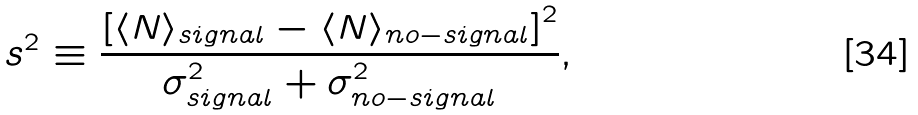<formula> <loc_0><loc_0><loc_500><loc_500>s ^ { 2 } \equiv \frac { { [ \langle N \rangle _ { s i g n a l } - \langle N \rangle _ { n o - s i g n a l } ] } ^ { 2 } } { \sigma ^ { 2 } _ { s i g n a l } + \sigma ^ { 2 } _ { n o - s i g n a l } } ,</formula> 